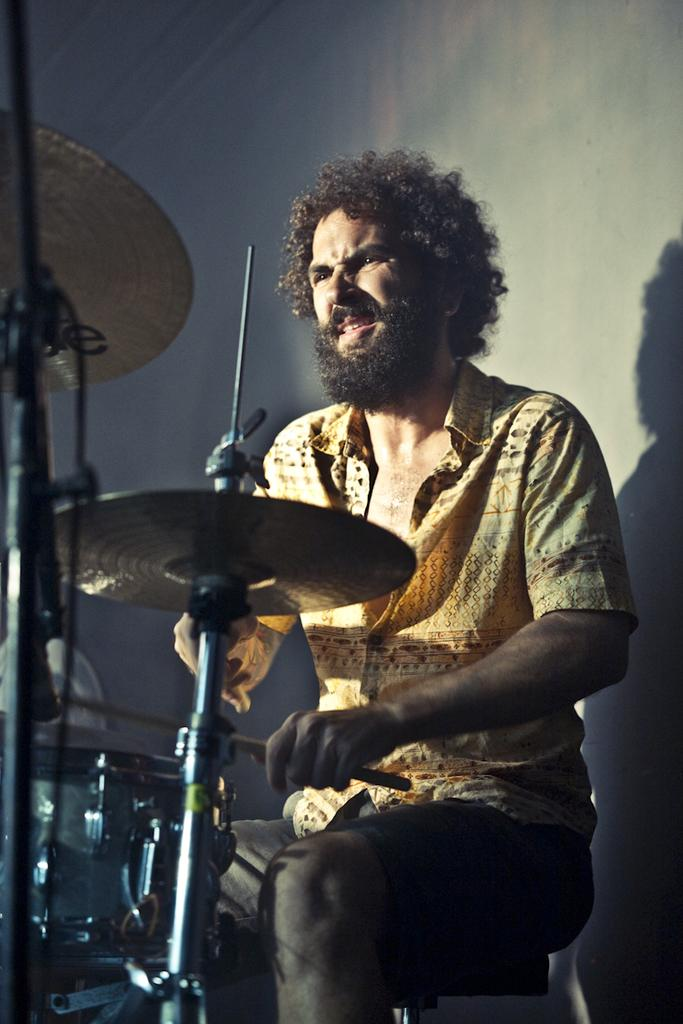What is the color of the wall in the image? The wall in the image is white. What is the man in the image doing? The man is playing musical drums in the image. How many horses are visible in the image? There are no horses present in the image. Is there a hose being used in the image? There is no hose visible in the image. 